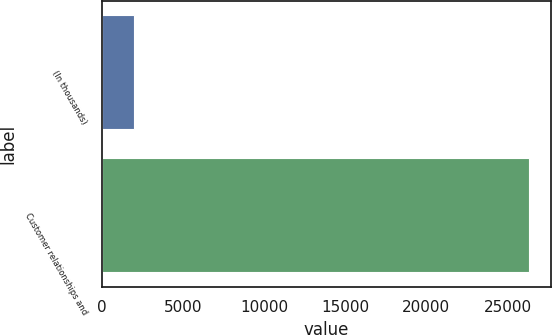<chart> <loc_0><loc_0><loc_500><loc_500><bar_chart><fcel>(In thousands)<fcel>Customer relationships and<nl><fcel>2013<fcel>26353<nl></chart> 